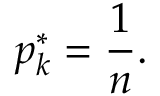<formula> <loc_0><loc_0><loc_500><loc_500>p _ { k } ^ { * } = { \frac { 1 } { n } } .</formula> 